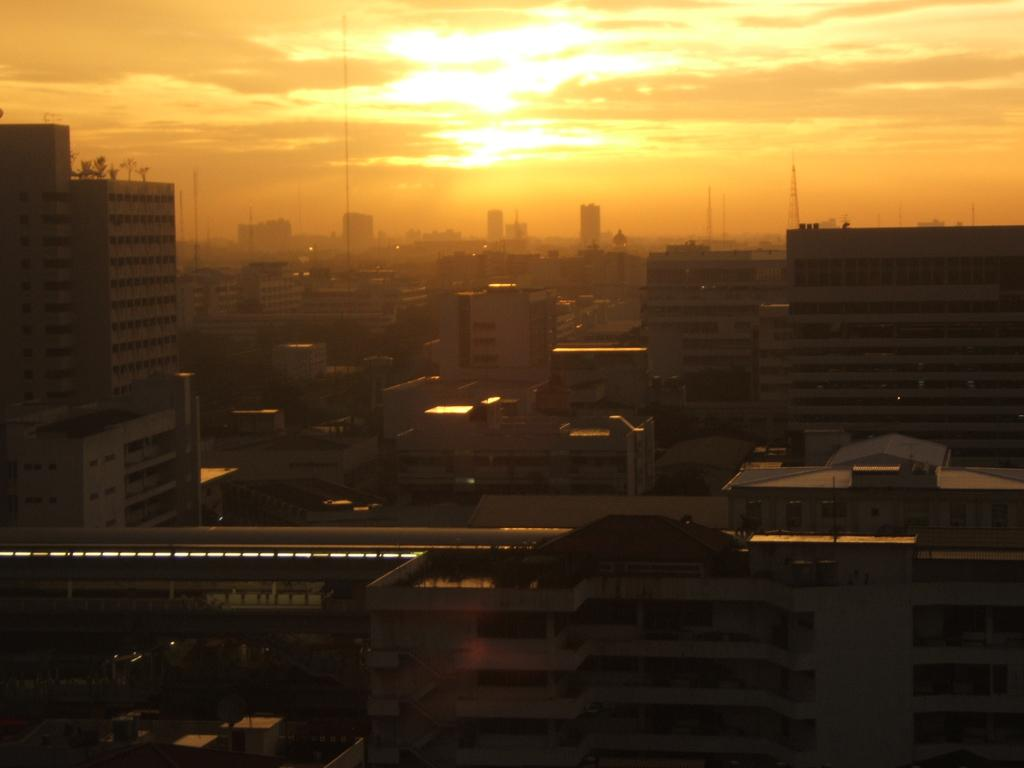What is the main subject in the center of the image? There is a train in the center of the image. What can be seen in the background of the image? There are buildings and the sun visible in the background of the image. What else is visible in the background of the image? The sky is also visible in the background of the image. Who is the owner of the train in the image? There is no information about the owner of the train in the image. What type of ink is used to draw the train in the image? The image is a photograph, not a drawing, so there is no ink used. 